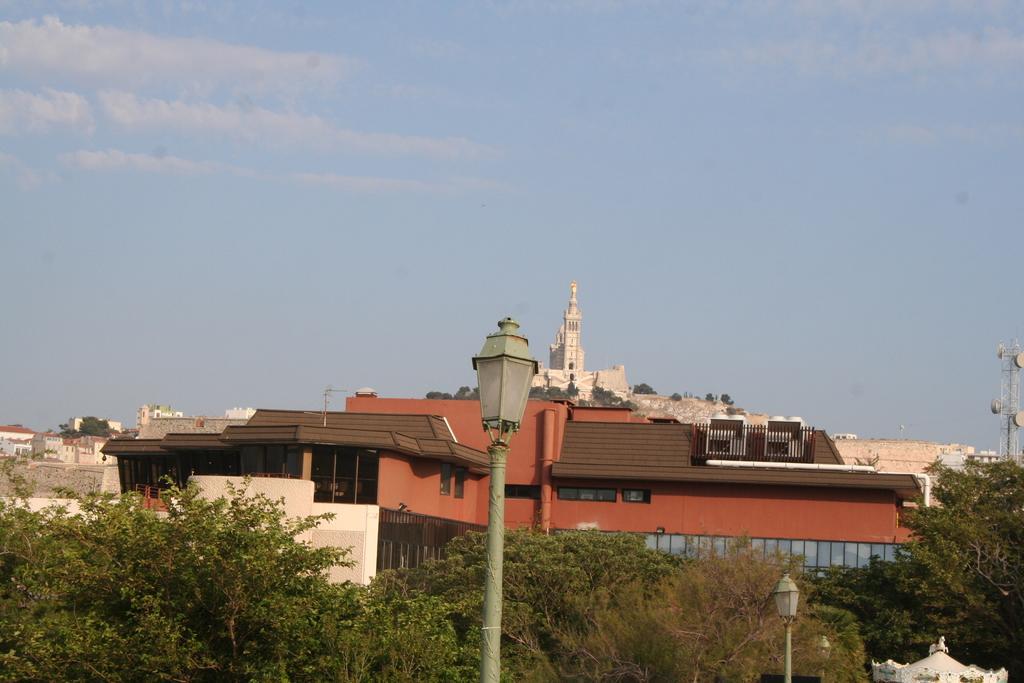How would you summarize this image in a sentence or two? In this image I can see trees in green color, for light poles. Background I can see buildings in brown and white color, I can also see sky in blue and white color. 